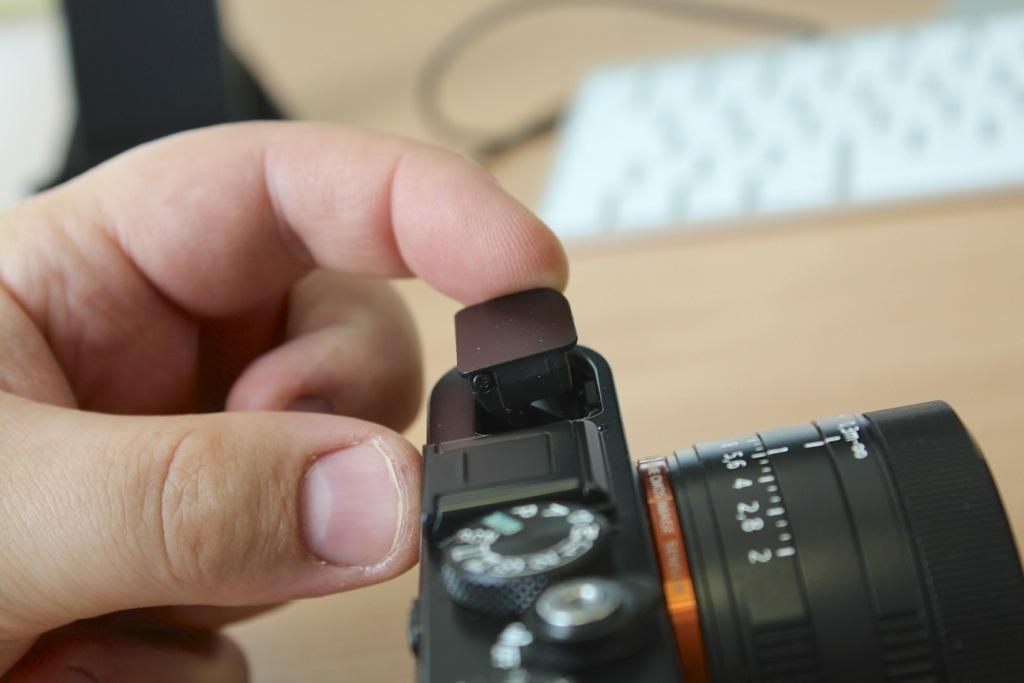What type of camera is visible in the image? There is a black color camera in the image. Can you describe any other elements in the image? Yes, there is a hand of a person in the image. What can be observed about the background of the image? The background of the image is blurred. Is there a badge visible on the person's hand in the image? There is no mention of a badge in the image, so it cannot be determined if one is present. 